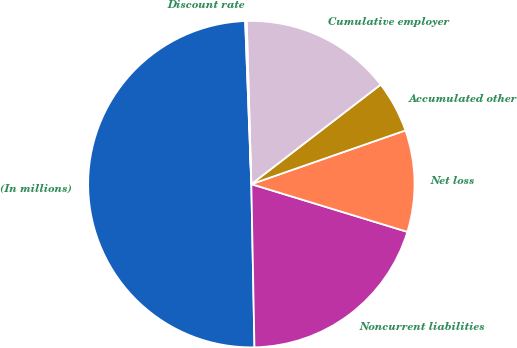<chart> <loc_0><loc_0><loc_500><loc_500><pie_chart><fcel>(In millions)<fcel>Noncurrent liabilities<fcel>Net loss<fcel>Accumulated other<fcel>Cumulative employer<fcel>Discount rate<nl><fcel>49.7%<fcel>19.97%<fcel>10.06%<fcel>5.1%<fcel>15.01%<fcel>0.15%<nl></chart> 